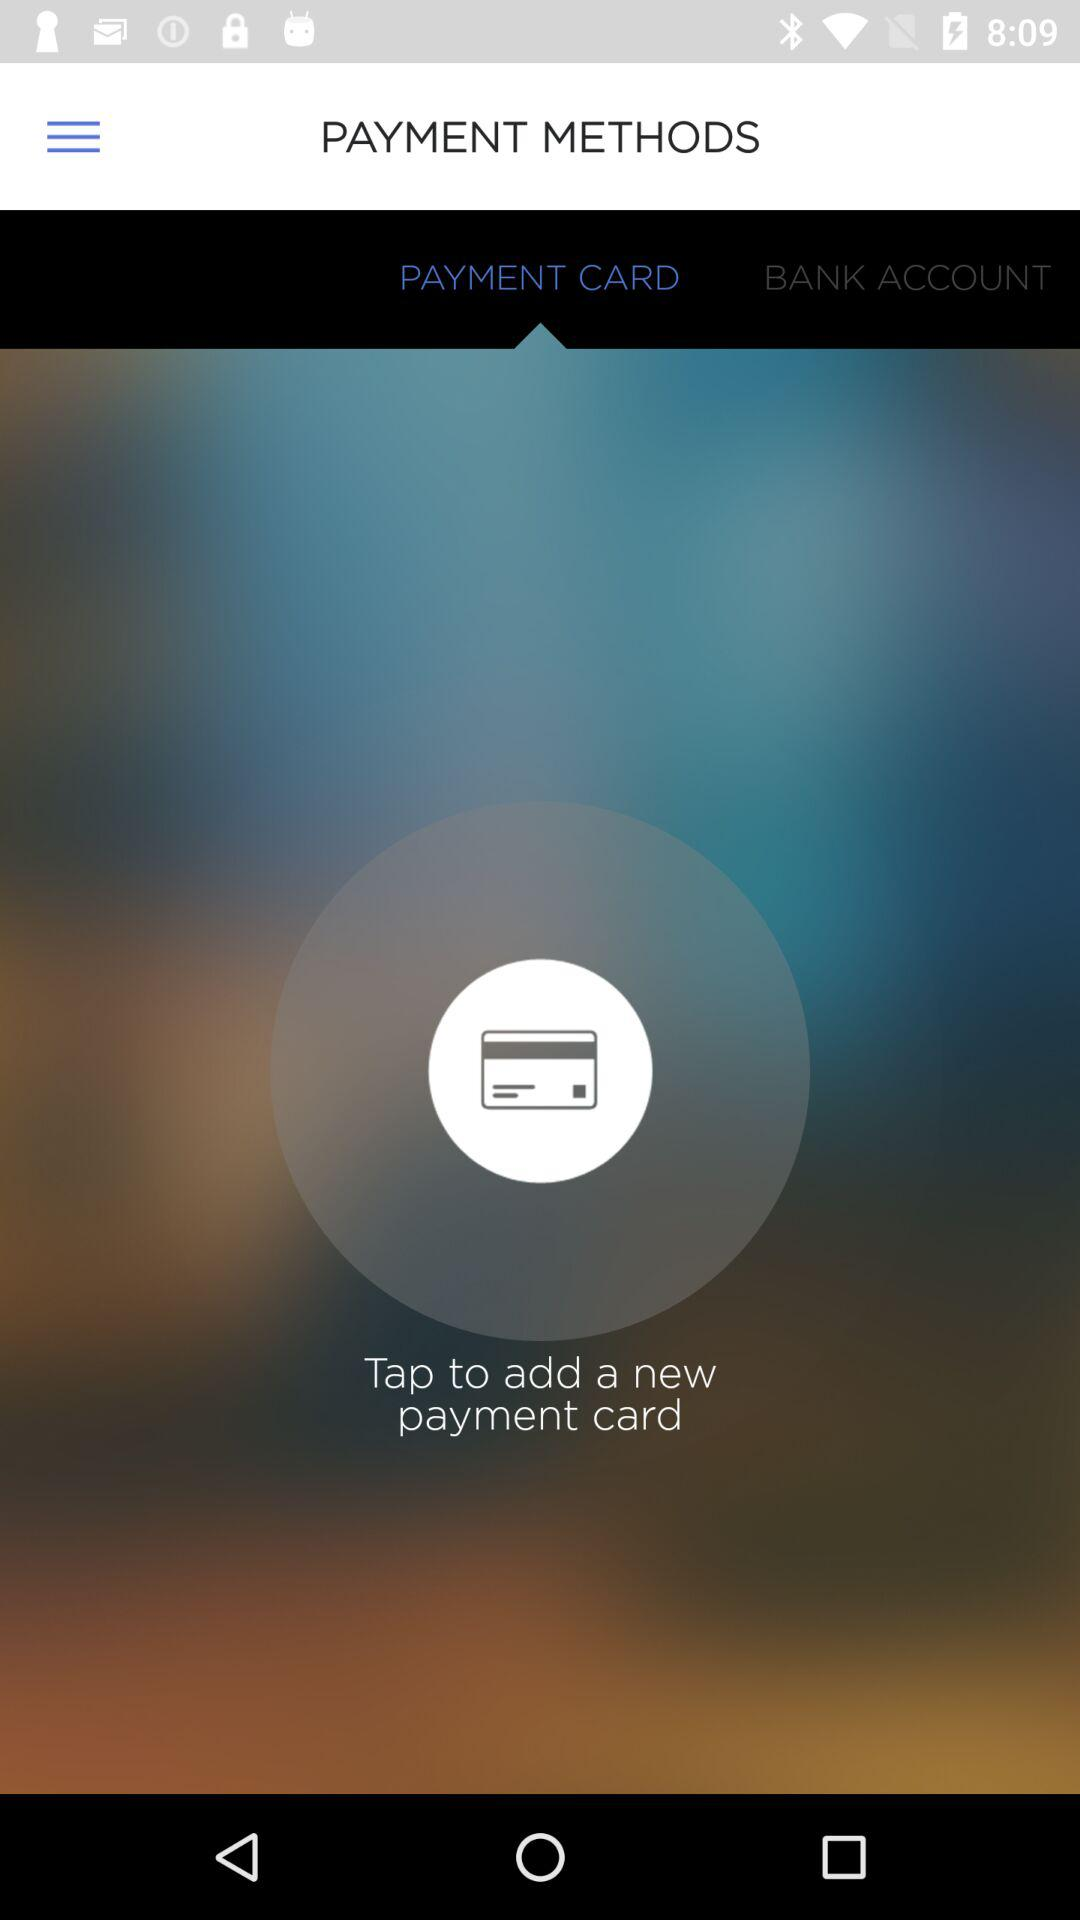Which method of payment has been selected? The payment method that has been selected is "PAYMENT CARD". 